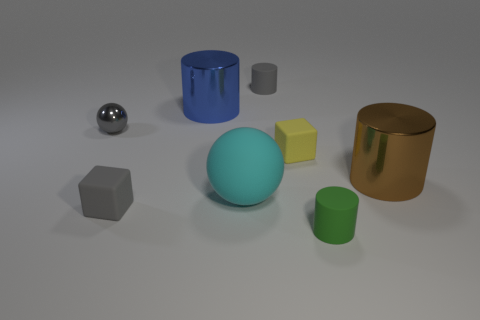Add 1 small green objects. How many objects exist? 9 Subtract all spheres. How many objects are left? 6 Add 8 small yellow blocks. How many small yellow blocks exist? 9 Subtract 0 red cubes. How many objects are left? 8 Subtract all yellow rubber objects. Subtract all big brown metallic cylinders. How many objects are left? 6 Add 4 matte blocks. How many matte blocks are left? 6 